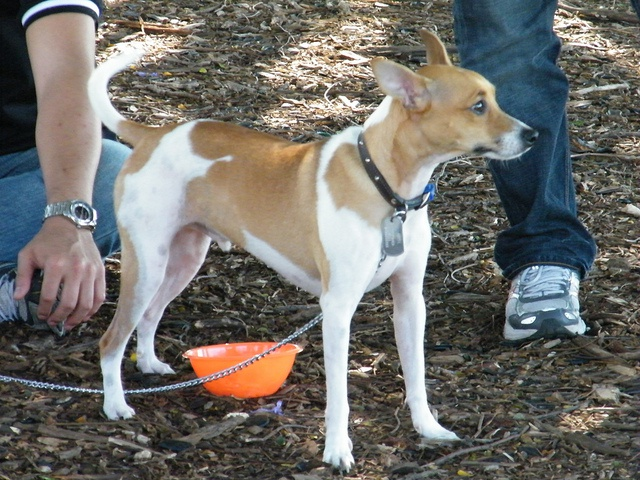Describe the objects in this image and their specific colors. I can see dog in black, lightgray, darkgray, tan, and gray tones, people in black, darkgray, and gray tones, people in black, blue, darkblue, and gray tones, and bowl in black, orange, red, and lightpink tones in this image. 